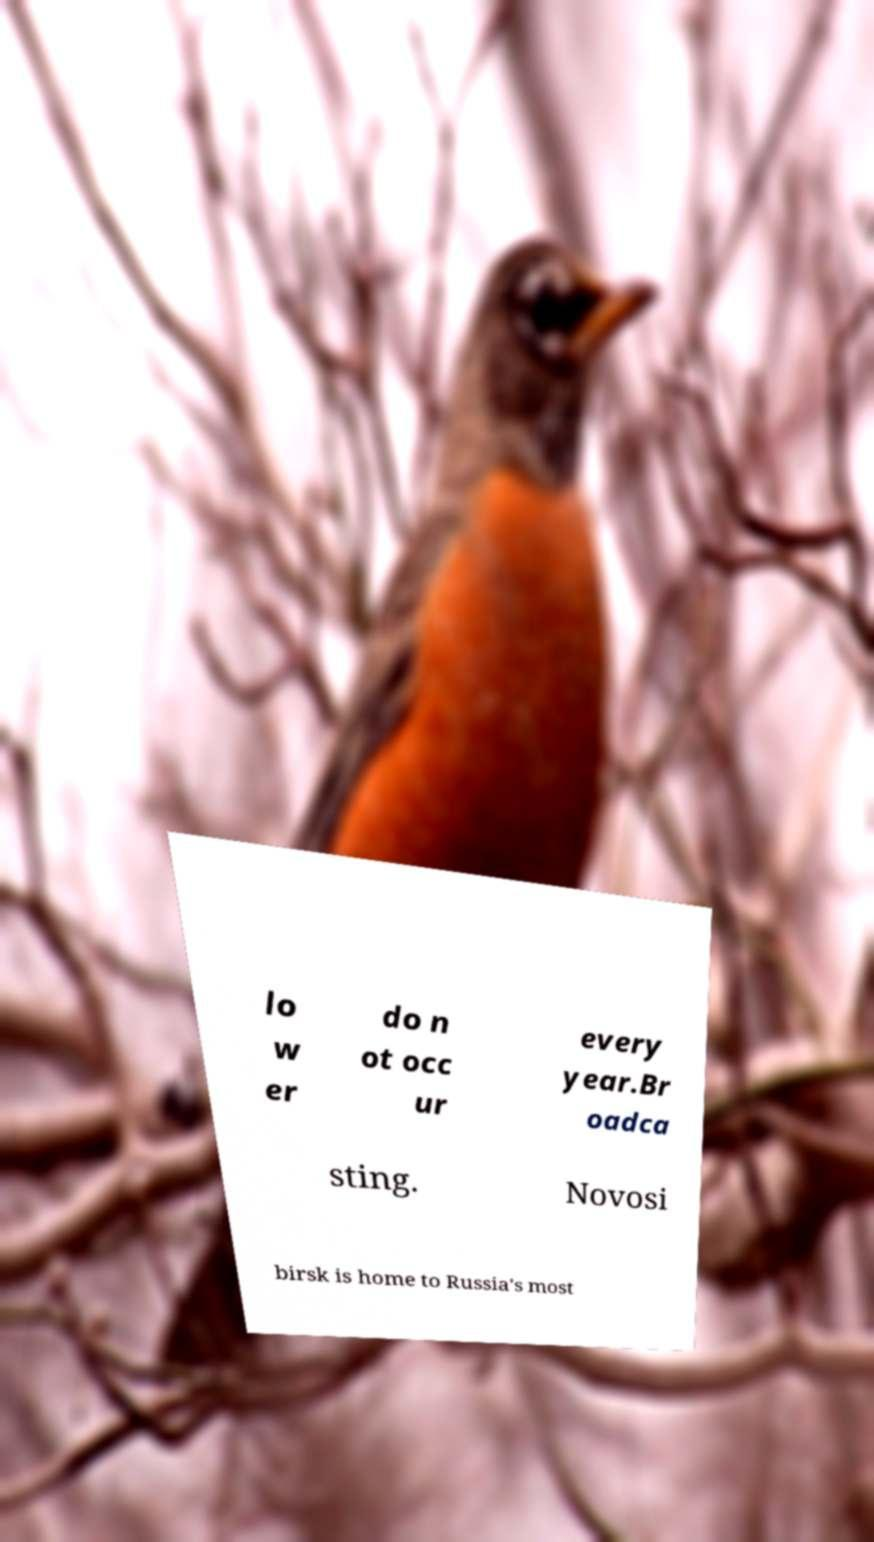Can you read and provide the text displayed in the image?This photo seems to have some interesting text. Can you extract and type it out for me? lo w er do n ot occ ur every year.Br oadca sting. Novosi birsk is home to Russia's most 